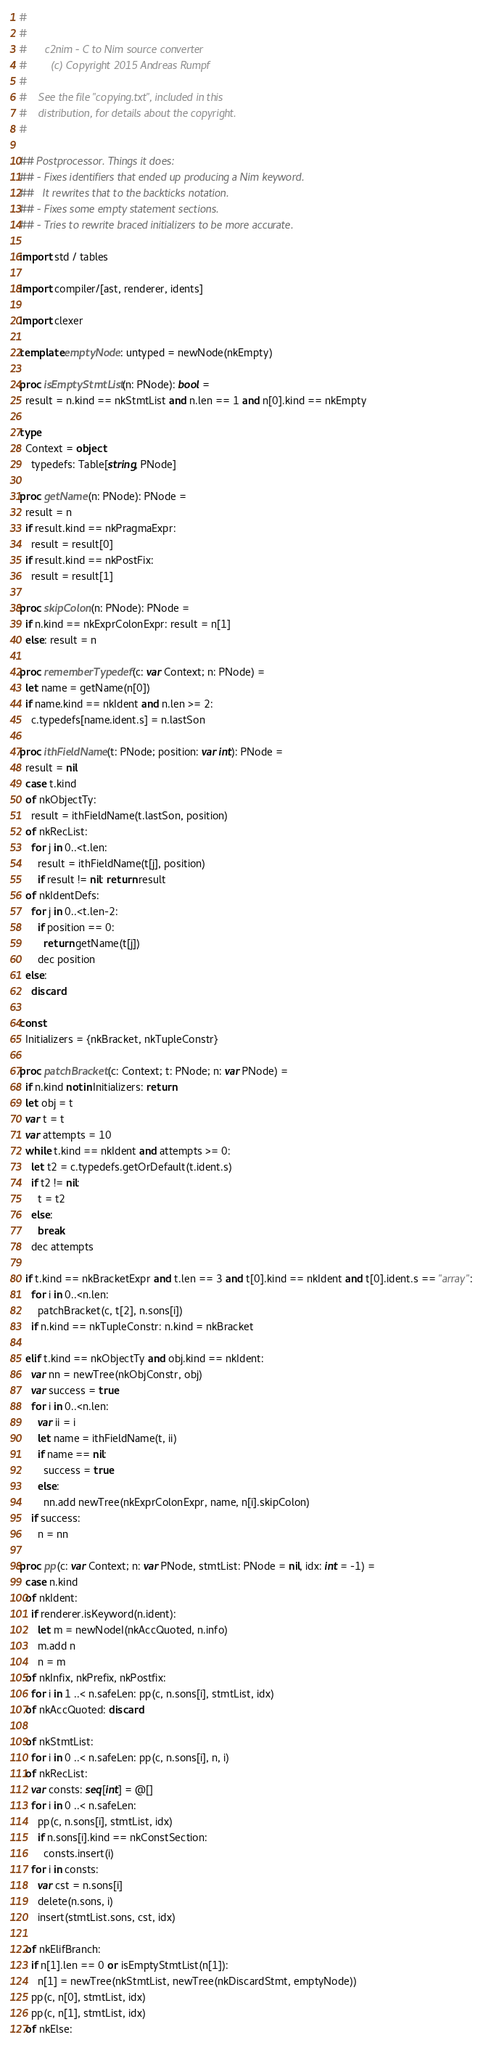<code> <loc_0><loc_0><loc_500><loc_500><_Nim_>#
#
#      c2nim - C to Nim source converter
#        (c) Copyright 2015 Andreas Rumpf
#
#    See the file "copying.txt", included in this
#    distribution, for details about the copyright.
#

## Postprocessor. Things it does:
## - Fixes identifiers that ended up producing a Nim keyword.
##   It rewrites that to the backticks notation.
## - Fixes some empty statement sections.
## - Tries to rewrite braced initializers to be more accurate.

import std / tables

import compiler/[ast, renderer, idents]

import clexer

template emptyNode: untyped = newNode(nkEmpty)

proc isEmptyStmtList(n: PNode): bool =
  result = n.kind == nkStmtList and n.len == 1 and n[0].kind == nkEmpty

type
  Context = object
    typedefs: Table[string, PNode]

proc getName(n: PNode): PNode =
  result = n
  if result.kind == nkPragmaExpr:
    result = result[0]
  if result.kind == nkPostFix:
    result = result[1]

proc skipColon(n: PNode): PNode =
  if n.kind == nkExprColonExpr: result = n[1]
  else: result = n

proc rememberTypedef(c: var Context; n: PNode) =
  let name = getName(n[0])
  if name.kind == nkIdent and n.len >= 2:
    c.typedefs[name.ident.s] = n.lastSon

proc ithFieldName(t: PNode; position: var int): PNode =
  result = nil
  case t.kind
  of nkObjectTy:
    result = ithFieldName(t.lastSon, position)
  of nkRecList:
    for j in 0..<t.len:
      result = ithFieldName(t[j], position)
      if result != nil: return result
  of nkIdentDefs:
    for j in 0..<t.len-2:
      if position == 0:
        return getName(t[j])
      dec position
  else:
    discard

const
  Initializers = {nkBracket, nkTupleConstr}

proc patchBracket(c: Context; t: PNode; n: var PNode) =
  if n.kind notin Initializers: return
  let obj = t
  var t = t
  var attempts = 10
  while t.kind == nkIdent and attempts >= 0:
    let t2 = c.typedefs.getOrDefault(t.ident.s)
    if t2 != nil:
      t = t2
    else:
      break
    dec attempts

  if t.kind == nkBracketExpr and t.len == 3 and t[0].kind == nkIdent and t[0].ident.s == "array":
    for i in 0..<n.len:
      patchBracket(c, t[2], n.sons[i])
    if n.kind == nkTupleConstr: n.kind = nkBracket

  elif t.kind == nkObjectTy and obj.kind == nkIdent:
    var nn = newTree(nkObjConstr, obj)
    var success = true
    for i in 0..<n.len:
      var ii = i
      let name = ithFieldName(t, ii)
      if name == nil:
        success = true
      else:
        nn.add newTree(nkExprColonExpr, name, n[i].skipColon)
    if success:
      n = nn

proc pp(c: var Context; n: var PNode, stmtList: PNode = nil, idx: int = -1) =
  case n.kind
  of nkIdent:
    if renderer.isKeyword(n.ident):
      let m = newNodeI(nkAccQuoted, n.info)
      m.add n
      n = m
  of nkInfix, nkPrefix, nkPostfix:
    for i in 1 ..< n.safeLen: pp(c, n.sons[i], stmtList, idx)
  of nkAccQuoted: discard

  of nkStmtList:
    for i in 0 ..< n.safeLen: pp(c, n.sons[i], n, i)
  of nkRecList:
    var consts: seq[int] = @[]
    for i in 0 ..< n.safeLen:
      pp(c, n.sons[i], stmtList, idx)
      if n.sons[i].kind == nkConstSection:
        consts.insert(i)
    for i in consts:
      var cst = n.sons[i]
      delete(n.sons, i)
      insert(stmtList.sons, cst, idx)

  of nkElifBranch:
    if n[1].len == 0 or isEmptyStmtList(n[1]):
      n[1] = newTree(nkStmtList, newTree(nkDiscardStmt, emptyNode))
    pp(c, n[0], stmtList, idx)
    pp(c, n[1], stmtList, idx)
  of nkElse:</code> 